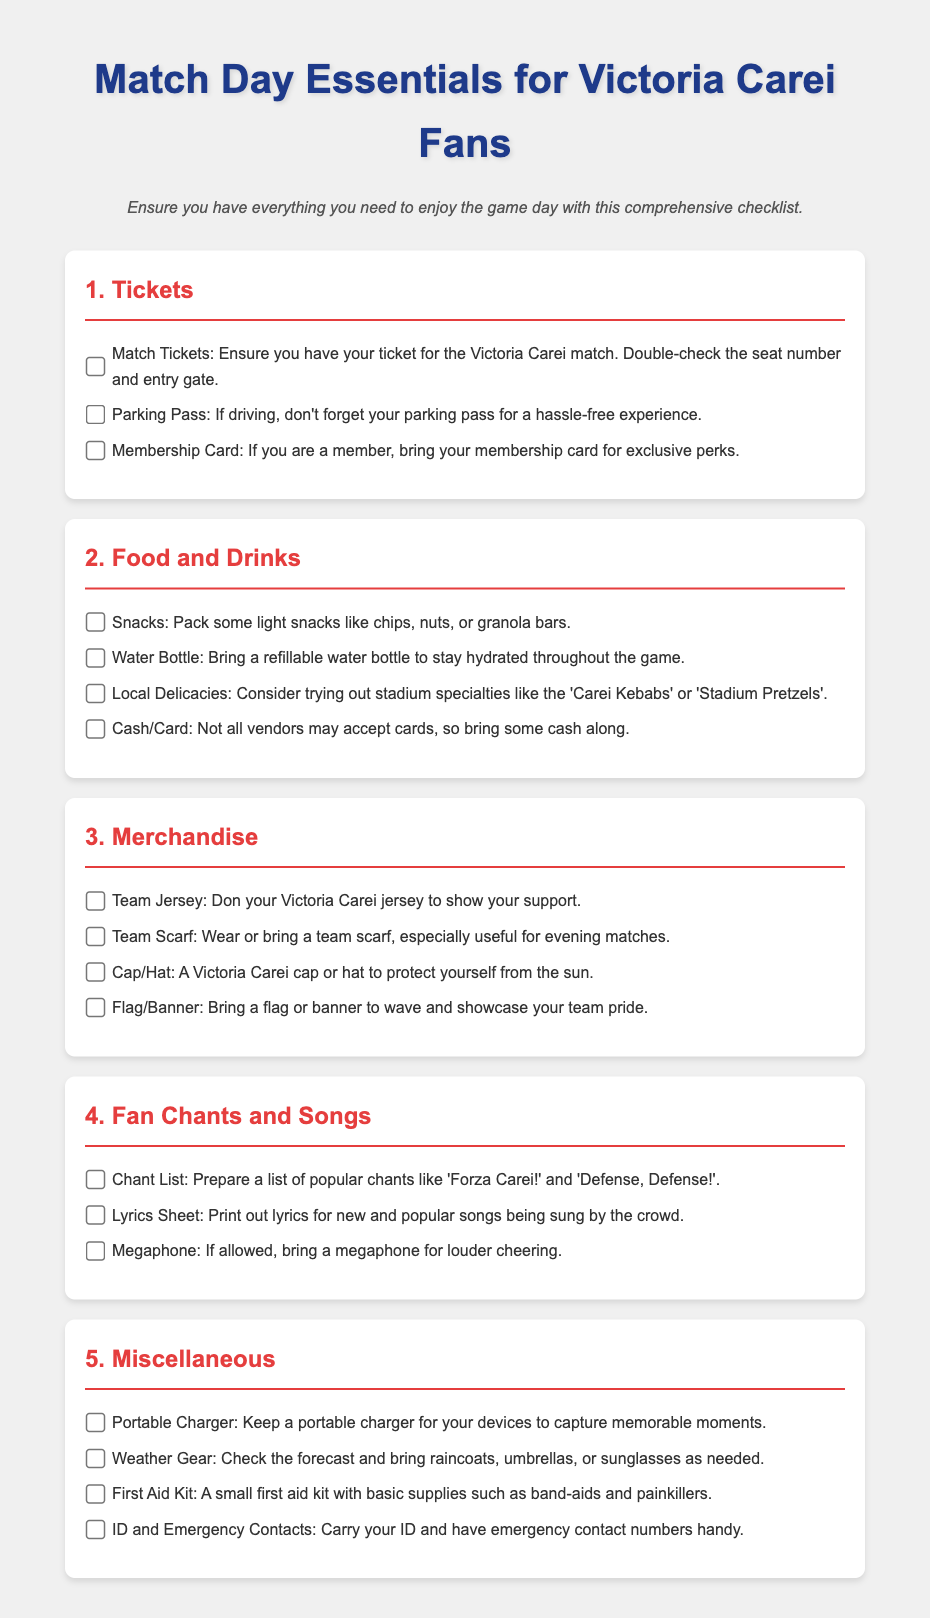what should you bring to ensure entry into the match? You should bring your match ticket, parking pass, and membership card for exclusive perks.
Answer: match ticket, parking pass, membership card name one local delicacy you should try at the stadium? The document mentions trying out 'Carei Kebabs' at the stadium, which is a local specialty.
Answer: Carei Kebabs what are two examples of merchandise to show your support? Examples include wearing a team jersey or bringing a team scarf.
Answer: team jersey, team scarf what is a key item to help you stay hydrated during the game? A refillable water bottle is recommended to stay hydrated throughout the game.
Answer: water bottle how many chants should you prepare for the match? The document suggests preparing a list of popular chants, although it does not specify a number.
Answer: a list what gear should you check before the match due to weather? You should check the weather forecast and bring items such as raincoats or sunglasses as necessary.
Answer: weather gear what device can help keep your phone charged during the game? A portable charger is suggested for keeping devices charged to capture moments.
Answer: portable charger what item would you bring to help amplify your cheering? The document mentions bringing a megaphone, if allowed, for louder cheering.
Answer: megaphone 